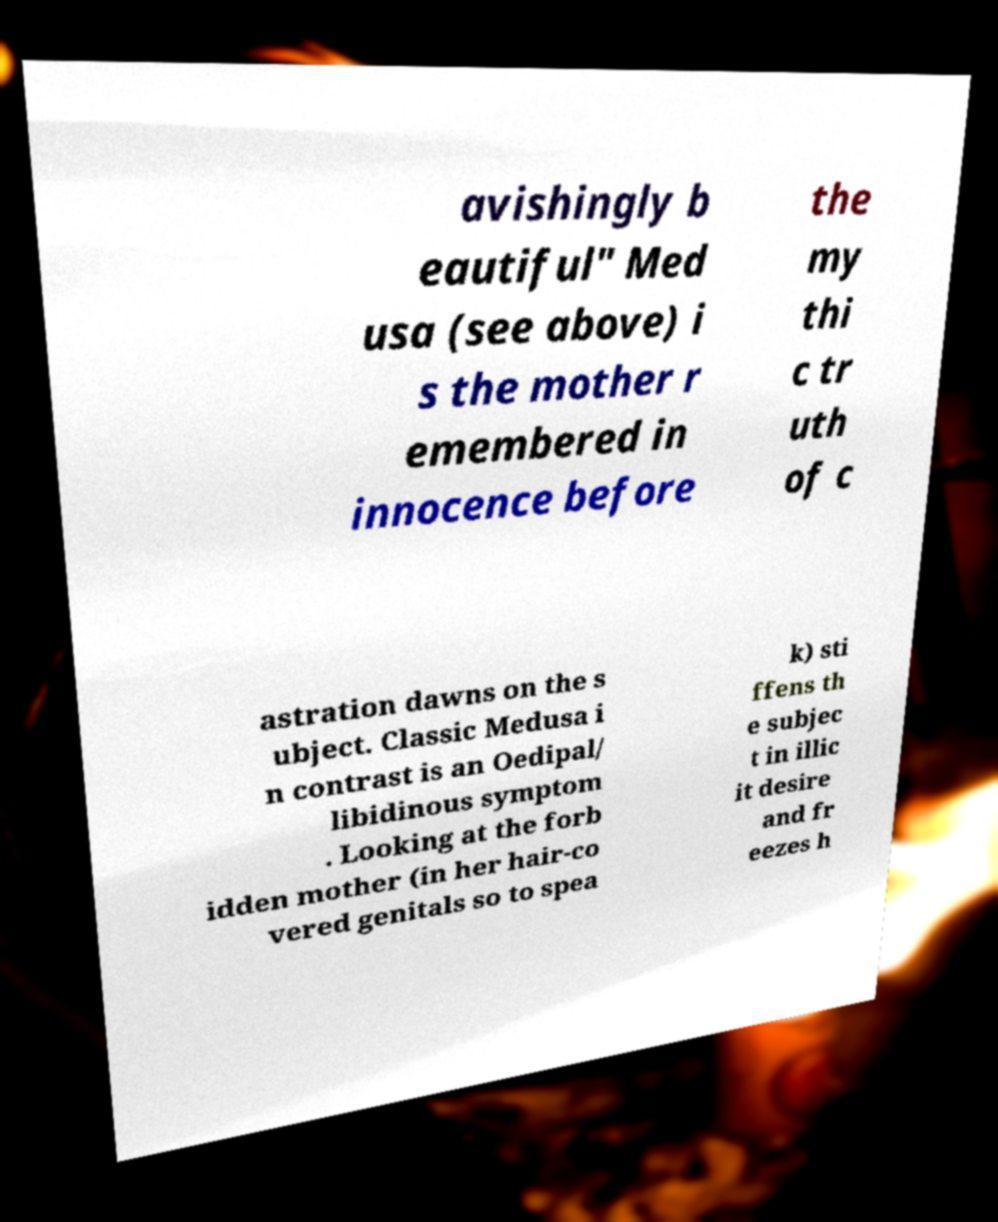I need the written content from this picture converted into text. Can you do that? avishingly b eautiful" Med usa (see above) i s the mother r emembered in innocence before the my thi c tr uth of c astration dawns on the s ubject. Classic Medusa i n contrast is an Oedipal/ libidinous symptom . Looking at the forb idden mother (in her hair-co vered genitals so to spea k) sti ffens th e subjec t in illic it desire and fr eezes h 